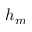<formula> <loc_0><loc_0><loc_500><loc_500>h _ { m }</formula> 